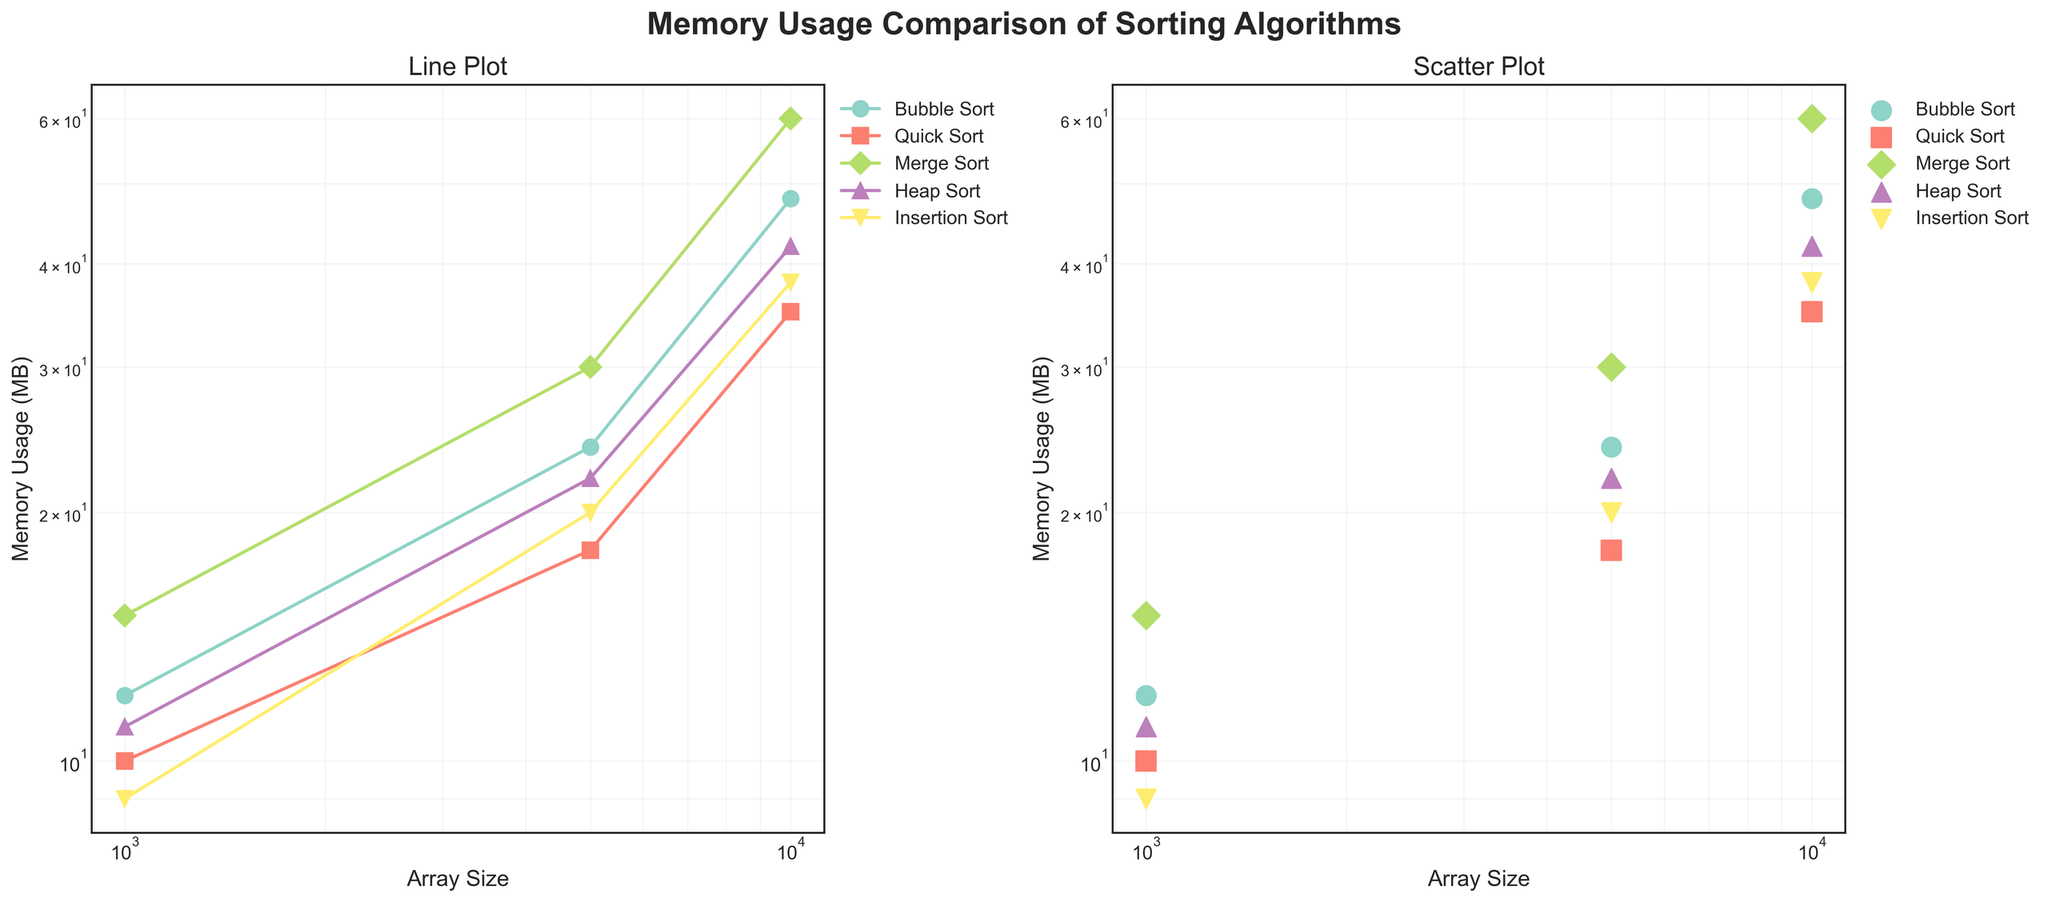What's the title of the figure? The title is displayed at the top of the figure and reads, "Memory Usage Comparison of Sorting Algorithms."
Answer: Memory Usage Comparison of Sorting Algorithms What are the axes labels in the figure? The x-axis is labeled as "Array Size" and the y-axis is labeled as "Memory Usage (MB)" in both subplots.
Answer: Array Size and Memory Usage (MB) Which sorting algorithm has the highest memory usage for an array size of 10000? By examining the data points for an array size of 10000 in both subplots, Merge Sort has the highest memory usage with 60 MB, surpassing the other algorithms.
Answer: Merge Sort How many algorithms are compared in the figure? The figure includes lines and markers for each algorithm. There are five different markers, corresponding to Bubble Sort, Quick Sort, Merge Sort, Heap Sort, and Insertion Sort.
Answer: 5 What array sizes are represented on the x-axis? By observing the x-axis tick marks in both subplots, the array sizes represented are 1000, 5000, and 10000.
Answer: 1000, 5000, and 10000 Which algorithm uses the least memory for an array size of 5000? For an array size of 5000, Insertion Sort has the least memory usage at 20 MB, as seen in both subplots.
Answer: Insertion Sort Compare the memory usage of Bubble Sort and Quick Sort for an array size of 5000. Which one is higher and by how much? At array size 5000, Bubble Sort uses 24 MB, while Quick Sort uses 18 MB. The difference is 24 - 18 = 6 MB, with Bubble Sort having higher memory usage.
Answer: Bubble Sort by 6 MB Considering the scatter plot, which algorithm shows the most consistent memory usage growth across different array sizes? By observing the scatter plot, Quick Sort demonstrates the most consistent growth in memory usage, with a clear and smooth progression from 1000 to 10000 in MB values.
Answer: Quick Sort What is the memory usage of Heap Sort for array sizes of 1000, 5000, and 10000? Heap Sort's memory usage is indicated by three points: 11 MB at 1000, 22 MB at 5000, and 42 MB at 10000, as shown in both plots.
Answer: 11, 22, and 42 MB Welke vragen zijn moeilijk en vereisen meerdere stappen redeneren? Ter referentie, vragen zoals "Vergelijk het geheugengebruik van Bubble Sort en Quick Sort voor een arraygrootte van 5000. Welke is hoger en met hoeveel?" vereisen het beoordelen van gegevenspunten voor beide algoritmen en er wiskundige bewerkingen op uitvoeren. Simpele vragen kunnen gemakkelijk worden beantwoord door de labels en zichtbare elementen op de grafiek te lezen.
Answer: vergelijkende vragen 